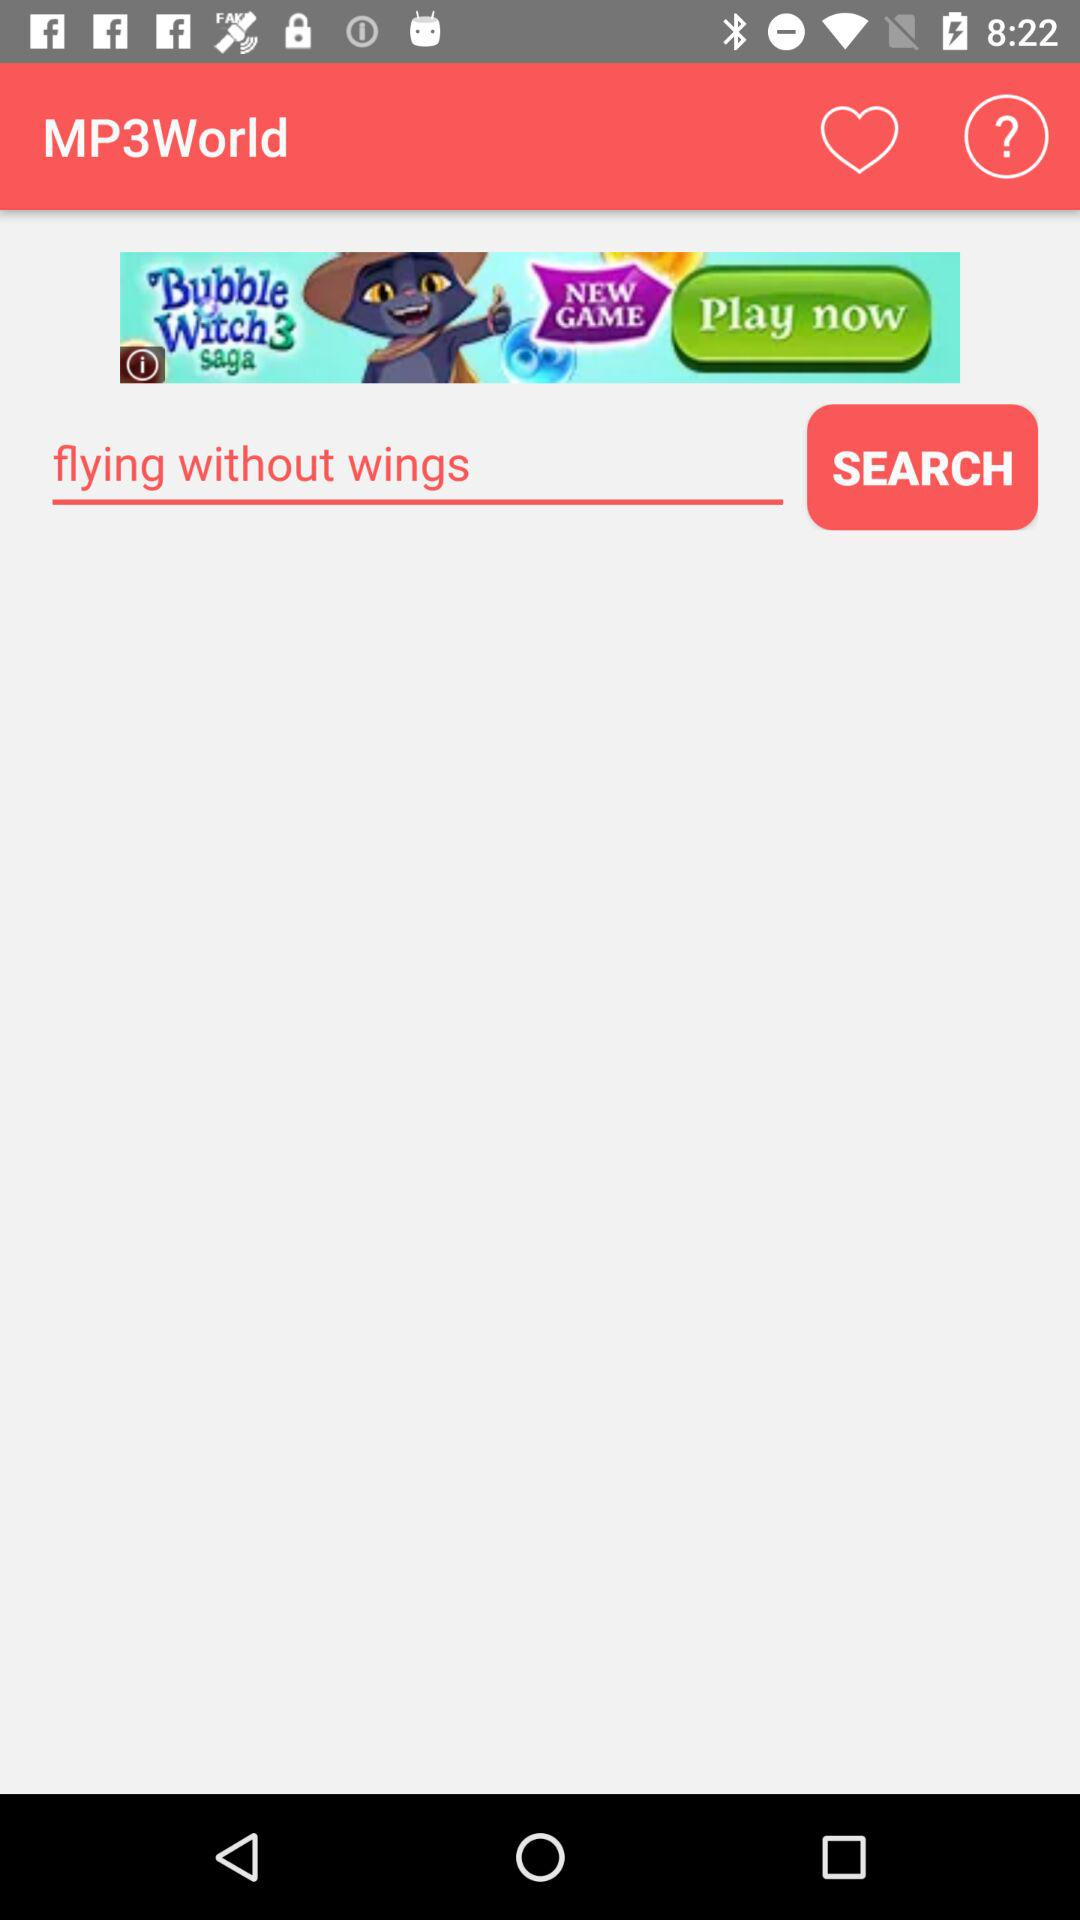What is the version of this application?
When the provided information is insufficient, respond with <no answer>. <no answer> 